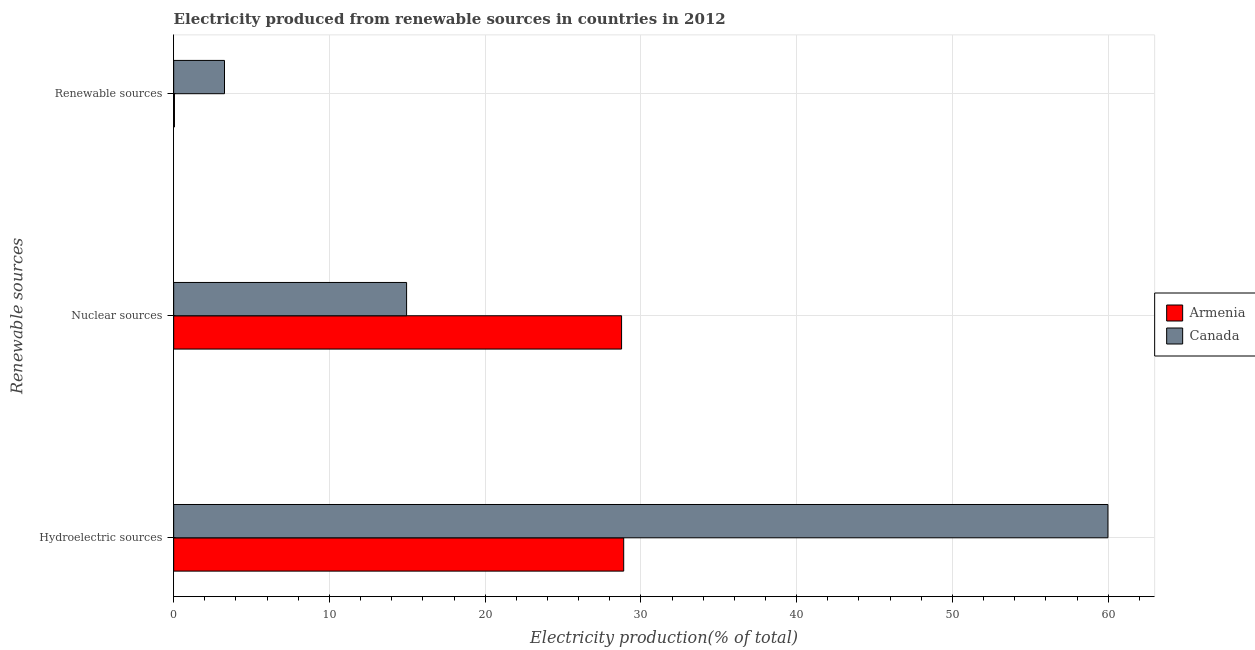Are the number of bars per tick equal to the number of legend labels?
Provide a succinct answer. Yes. Are the number of bars on each tick of the Y-axis equal?
Provide a succinct answer. Yes. How many bars are there on the 1st tick from the bottom?
Make the answer very short. 2. What is the label of the 3rd group of bars from the top?
Offer a very short reply. Hydroelectric sources. What is the percentage of electricity produced by nuclear sources in Canada?
Your response must be concise. 14.95. Across all countries, what is the maximum percentage of electricity produced by renewable sources?
Your answer should be compact. 3.26. Across all countries, what is the minimum percentage of electricity produced by renewable sources?
Your answer should be very brief. 0.05. In which country was the percentage of electricity produced by hydroelectric sources minimum?
Your response must be concise. Armenia. What is the total percentage of electricity produced by hydroelectric sources in the graph?
Offer a very short reply. 88.88. What is the difference between the percentage of electricity produced by renewable sources in Armenia and that in Canada?
Offer a terse response. -3.21. What is the difference between the percentage of electricity produced by nuclear sources in Canada and the percentage of electricity produced by renewable sources in Armenia?
Make the answer very short. 14.9. What is the average percentage of electricity produced by nuclear sources per country?
Your answer should be very brief. 21.86. What is the difference between the percentage of electricity produced by hydroelectric sources and percentage of electricity produced by nuclear sources in Canada?
Make the answer very short. 45.03. In how many countries, is the percentage of electricity produced by nuclear sources greater than 8 %?
Offer a very short reply. 2. What is the ratio of the percentage of electricity produced by renewable sources in Armenia to that in Canada?
Provide a succinct answer. 0.02. Is the percentage of electricity produced by hydroelectric sources in Armenia less than that in Canada?
Make the answer very short. Yes. What is the difference between the highest and the second highest percentage of electricity produced by renewable sources?
Offer a very short reply. 3.21. What is the difference between the highest and the lowest percentage of electricity produced by hydroelectric sources?
Provide a short and direct response. 31.09. In how many countries, is the percentage of electricity produced by nuclear sources greater than the average percentage of electricity produced by nuclear sources taken over all countries?
Your answer should be very brief. 1. What does the 2nd bar from the top in Nuclear sources represents?
Give a very brief answer. Armenia. What does the 1st bar from the bottom in Renewable sources represents?
Ensure brevity in your answer.  Armenia. Is it the case that in every country, the sum of the percentage of electricity produced by hydroelectric sources and percentage of electricity produced by nuclear sources is greater than the percentage of electricity produced by renewable sources?
Your answer should be very brief. Yes. Are all the bars in the graph horizontal?
Make the answer very short. Yes. What is the difference between two consecutive major ticks on the X-axis?
Make the answer very short. 10. Does the graph contain grids?
Provide a succinct answer. Yes. How many legend labels are there?
Offer a very short reply. 2. How are the legend labels stacked?
Your answer should be compact. Vertical. What is the title of the graph?
Keep it short and to the point. Electricity produced from renewable sources in countries in 2012. What is the label or title of the Y-axis?
Keep it short and to the point. Renewable sources. What is the Electricity production(% of total) of Armenia in Hydroelectric sources?
Your response must be concise. 28.89. What is the Electricity production(% of total) of Canada in Hydroelectric sources?
Your answer should be compact. 59.99. What is the Electricity production(% of total) of Armenia in Nuclear sources?
Keep it short and to the point. 28.76. What is the Electricity production(% of total) of Canada in Nuclear sources?
Give a very brief answer. 14.95. What is the Electricity production(% of total) in Armenia in Renewable sources?
Offer a very short reply. 0.05. What is the Electricity production(% of total) in Canada in Renewable sources?
Make the answer very short. 3.26. Across all Renewable sources, what is the maximum Electricity production(% of total) of Armenia?
Offer a very short reply. 28.89. Across all Renewable sources, what is the maximum Electricity production(% of total) in Canada?
Provide a succinct answer. 59.99. Across all Renewable sources, what is the minimum Electricity production(% of total) in Armenia?
Ensure brevity in your answer.  0.05. Across all Renewable sources, what is the minimum Electricity production(% of total) in Canada?
Your answer should be very brief. 3.26. What is the total Electricity production(% of total) of Armenia in the graph?
Your response must be concise. 57.7. What is the total Electricity production(% of total) of Canada in the graph?
Ensure brevity in your answer.  78.2. What is the difference between the Electricity production(% of total) in Armenia in Hydroelectric sources and that in Nuclear sources?
Offer a terse response. 0.14. What is the difference between the Electricity production(% of total) of Canada in Hydroelectric sources and that in Nuclear sources?
Keep it short and to the point. 45.03. What is the difference between the Electricity production(% of total) of Armenia in Hydroelectric sources and that in Renewable sources?
Offer a very short reply. 28.85. What is the difference between the Electricity production(% of total) in Canada in Hydroelectric sources and that in Renewable sources?
Your response must be concise. 56.72. What is the difference between the Electricity production(% of total) in Armenia in Nuclear sources and that in Renewable sources?
Provide a succinct answer. 28.71. What is the difference between the Electricity production(% of total) of Canada in Nuclear sources and that in Renewable sources?
Your answer should be compact. 11.69. What is the difference between the Electricity production(% of total) in Armenia in Hydroelectric sources and the Electricity production(% of total) in Canada in Nuclear sources?
Provide a short and direct response. 13.94. What is the difference between the Electricity production(% of total) of Armenia in Hydroelectric sources and the Electricity production(% of total) of Canada in Renewable sources?
Provide a succinct answer. 25.63. What is the difference between the Electricity production(% of total) of Armenia in Nuclear sources and the Electricity production(% of total) of Canada in Renewable sources?
Give a very brief answer. 25.5. What is the average Electricity production(% of total) in Armenia per Renewable sources?
Keep it short and to the point. 19.23. What is the average Electricity production(% of total) in Canada per Renewable sources?
Give a very brief answer. 26.07. What is the difference between the Electricity production(% of total) of Armenia and Electricity production(% of total) of Canada in Hydroelectric sources?
Offer a terse response. -31.09. What is the difference between the Electricity production(% of total) in Armenia and Electricity production(% of total) in Canada in Nuclear sources?
Provide a succinct answer. 13.8. What is the difference between the Electricity production(% of total) of Armenia and Electricity production(% of total) of Canada in Renewable sources?
Make the answer very short. -3.21. What is the ratio of the Electricity production(% of total) in Armenia in Hydroelectric sources to that in Nuclear sources?
Your answer should be very brief. 1. What is the ratio of the Electricity production(% of total) of Canada in Hydroelectric sources to that in Nuclear sources?
Your response must be concise. 4.01. What is the ratio of the Electricity production(% of total) in Armenia in Hydroelectric sources to that in Renewable sources?
Make the answer very short. 580.5. What is the ratio of the Electricity production(% of total) in Canada in Hydroelectric sources to that in Renewable sources?
Offer a very short reply. 18.38. What is the ratio of the Electricity production(% of total) in Armenia in Nuclear sources to that in Renewable sources?
Provide a succinct answer. 577.75. What is the ratio of the Electricity production(% of total) in Canada in Nuclear sources to that in Renewable sources?
Offer a terse response. 4.58. What is the difference between the highest and the second highest Electricity production(% of total) in Armenia?
Keep it short and to the point. 0.14. What is the difference between the highest and the second highest Electricity production(% of total) in Canada?
Your answer should be compact. 45.03. What is the difference between the highest and the lowest Electricity production(% of total) in Armenia?
Offer a very short reply. 28.85. What is the difference between the highest and the lowest Electricity production(% of total) of Canada?
Give a very brief answer. 56.72. 